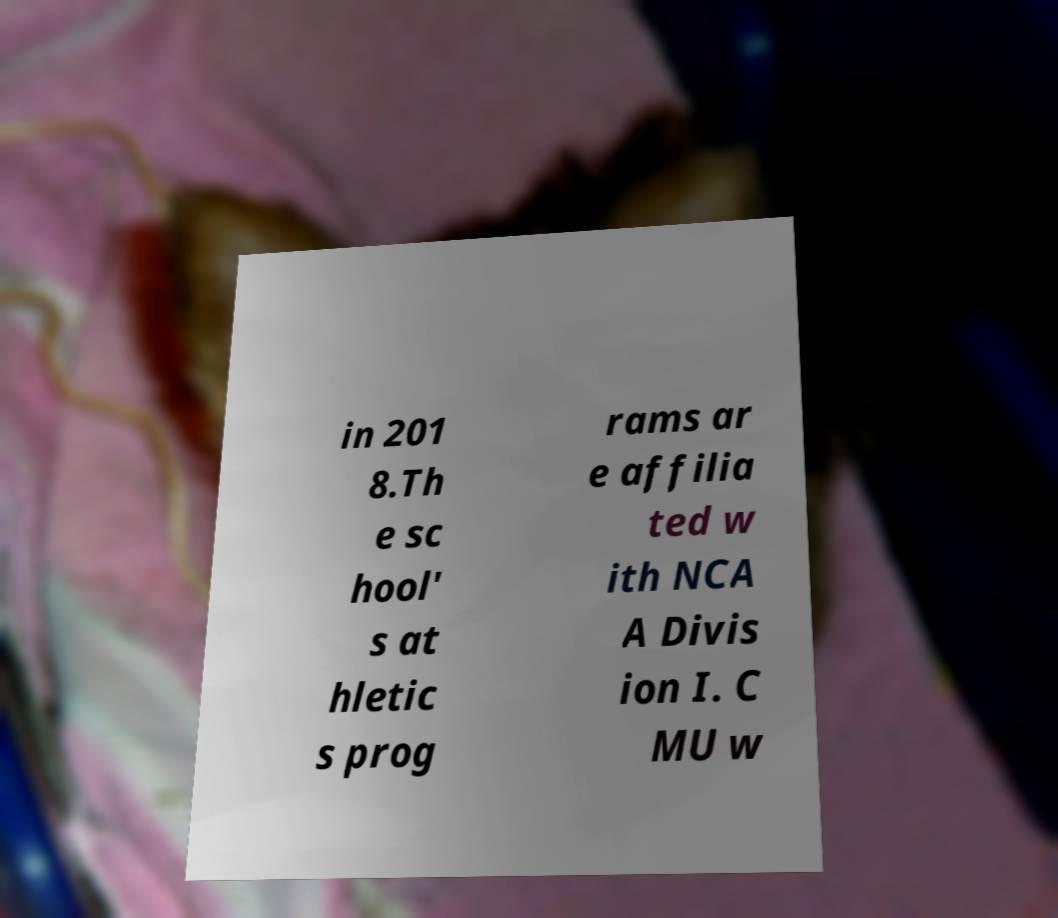I need the written content from this picture converted into text. Can you do that? in 201 8.Th e sc hool' s at hletic s prog rams ar e affilia ted w ith NCA A Divis ion I. C MU w 